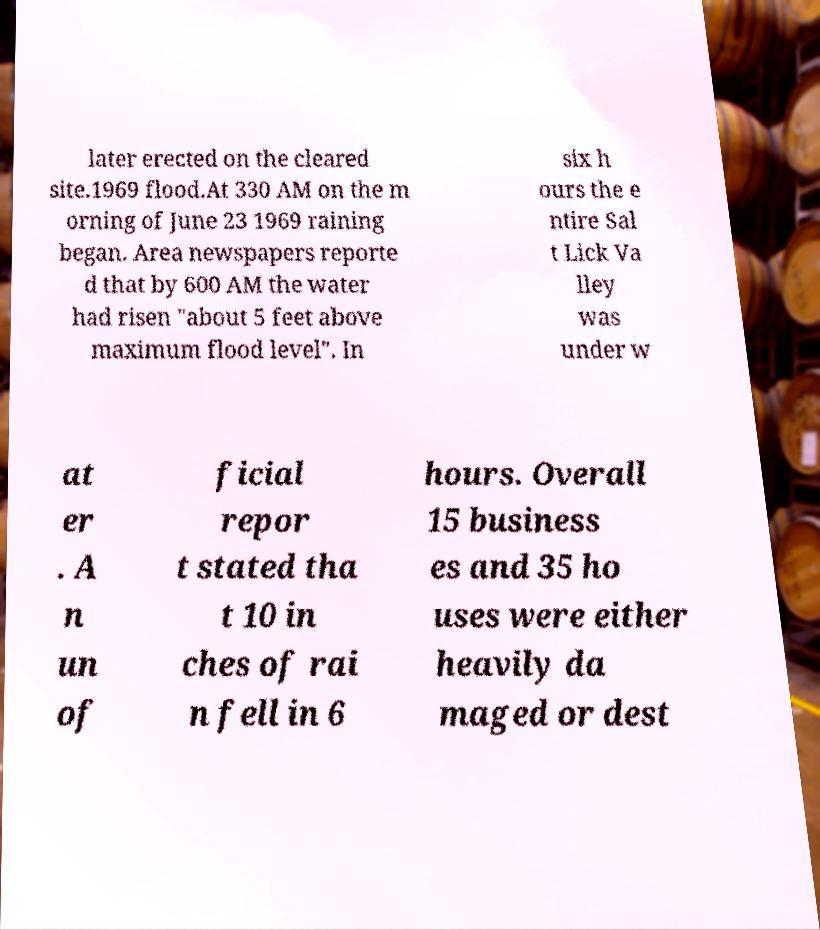Can you accurately transcribe the text from the provided image for me? later erected on the cleared site.1969 flood.At 330 AM on the m orning of June 23 1969 raining began. Area newspapers reporte d that by 600 AM the water had risen "about 5 feet above maximum flood level". In six h ours the e ntire Sal t Lick Va lley was under w at er . A n un of ficial repor t stated tha t 10 in ches of rai n fell in 6 hours. Overall 15 business es and 35 ho uses were either heavily da maged or dest 